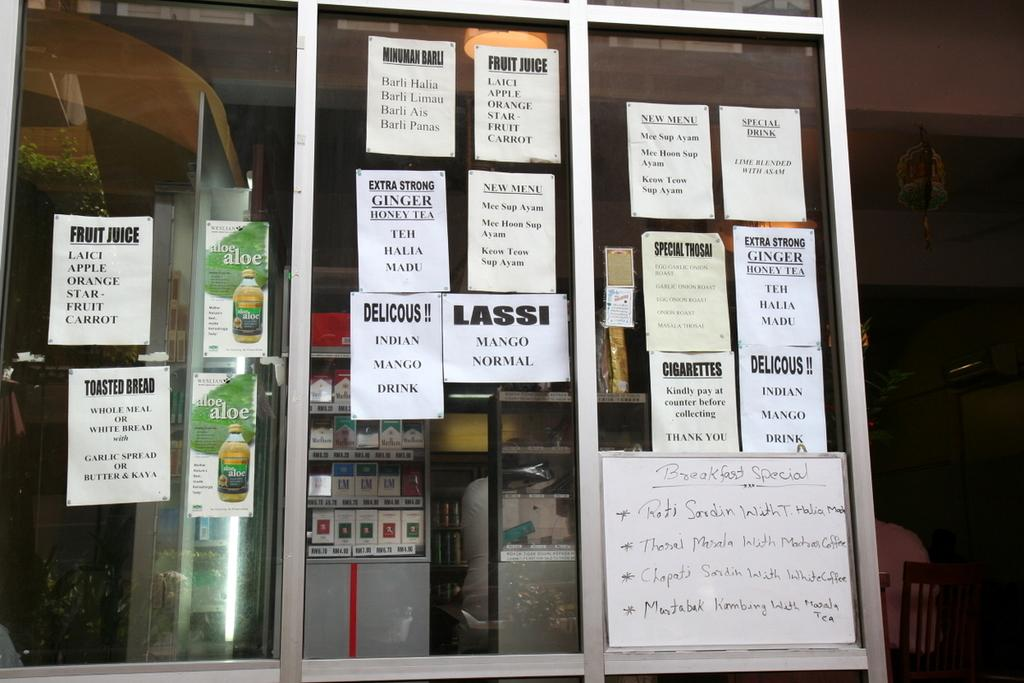<image>
Describe the image concisely. A window with many paper signs on it, one reads Delicious Indian mango drink 